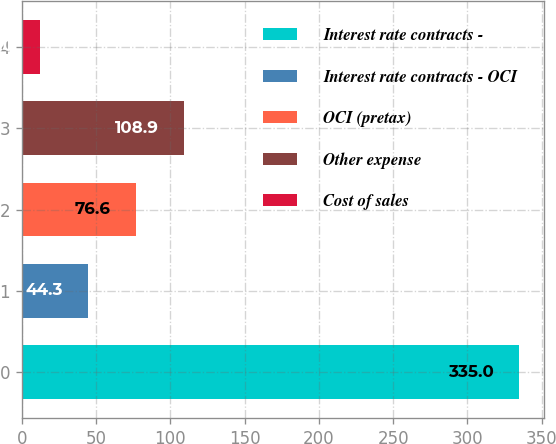Convert chart to OTSL. <chart><loc_0><loc_0><loc_500><loc_500><bar_chart><fcel>Interest rate contracts -<fcel>Interest rate contracts - OCI<fcel>OCI (pretax)<fcel>Other expense<fcel>Cost of sales<nl><fcel>335<fcel>44.3<fcel>76.6<fcel>108.9<fcel>12<nl></chart> 